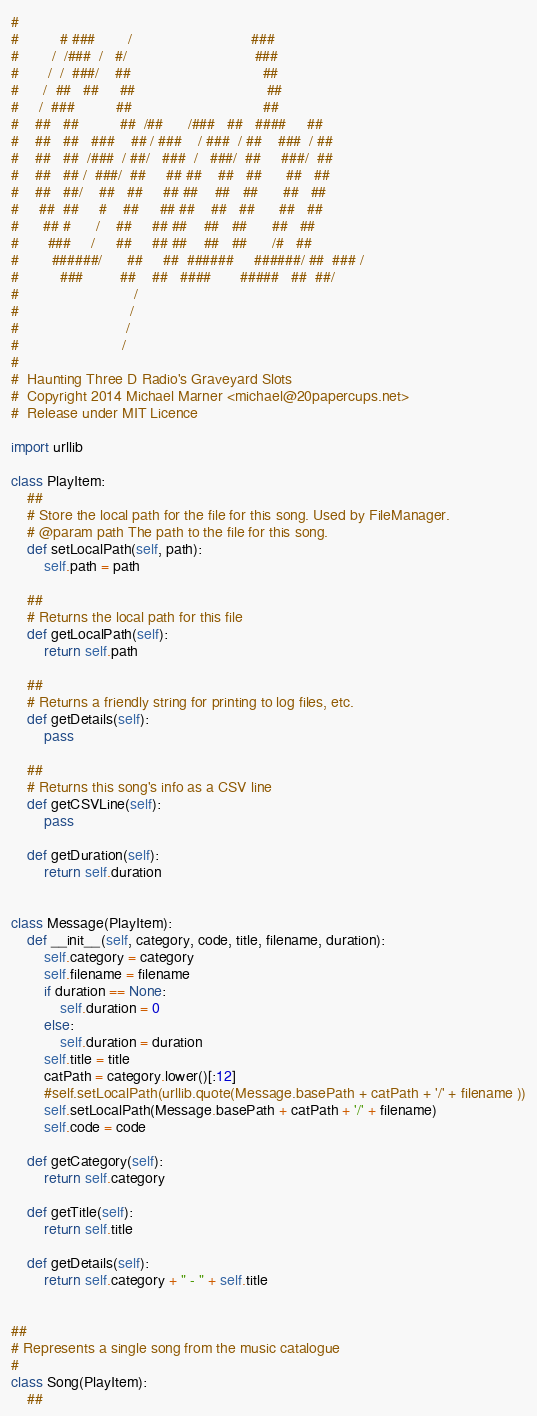Convert code to text. <code><loc_0><loc_0><loc_500><loc_500><_Python_>#                                                             
#          # ###        /                             ###     
#        /  /###  /   #/                               ###    
#       /  /  ###/    ##                                ##    
#      /  ##   ##     ##                                ##    
#     /  ###          ##                                ##    
#    ##   ##          ##  /##      /###   ##   ####     ##    
#    ##   ##   ###    ## / ###    / ###  / ##    ###  / ##    
#    ##   ##  /###  / ##/   ###  /   ###/  ##     ###/  ##    
#    ##   ## /  ###/  ##     ## ##    ##   ##      ##   ##    
#    ##   ##/    ##   ##     ## ##    ##   ##      ##   ##    
#     ##  ##     #    ##     ## ##    ##   ##      ##   ##    
#      ## #      /    ##     ## ##    ##   ##      ##   ##    
#       ###     /     ##     ## ##    ##   ##      /#   ##    
#        ######/      ##     ##  ######     ######/ ##  ### / 
#          ###         ##    ##   ####       #####   ##  ##/  
#                            /                                
#                           /                                 
#                          /                                  
#                         /                                   
#
#  Haunting Three D Radio's Graveyard Slots
#  Copyright 2014 Michael Marner <michael@20papercups.net>
#  Release under MIT Licence

import urllib

class PlayItem:
    ##
    # Store the local path for the file for this song. Used by FileManager.
    # @param path The path to the file for this song.
    def setLocalPath(self, path):
        self.path = path

    ##
    # Returns the local path for this file
    def getLocalPath(self):
        return self.path

    ##
    # Returns a friendly string for printing to log files, etc.
    def getDetails(self):
        pass

    ##
    # Returns this song's info as a CSV line
    def getCSVLine(self):
        pass

    def getDuration(self):
        return self.duration


class Message(PlayItem):
    def __init__(self, category, code, title, filename, duration):
        self.category = category
        self.filename = filename
        if duration == None:
            self.duration = 0
        else:
            self.duration = duration
        self.title = title  
        catPath = category.lower()[:12]
        #self.setLocalPath(urllib.quote(Message.basePath + catPath + '/' + filename ))
        self.setLocalPath(Message.basePath + catPath + '/' + filename)
        self.code = code

    def getCategory(self):
        return self.category

    def getTitle(self):
        return self.title

    def getDetails(self):
        return self.category + " - " + self.title


##
# Represents a single song from the music catalogue
#
class Song(PlayItem):
    ##</code> 